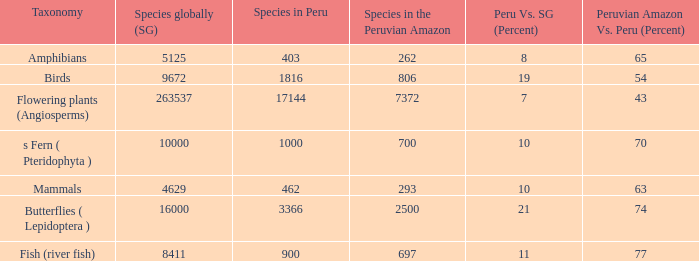What's the maximum peru vs. world (percent) with 9672 species in the world  19.0. 